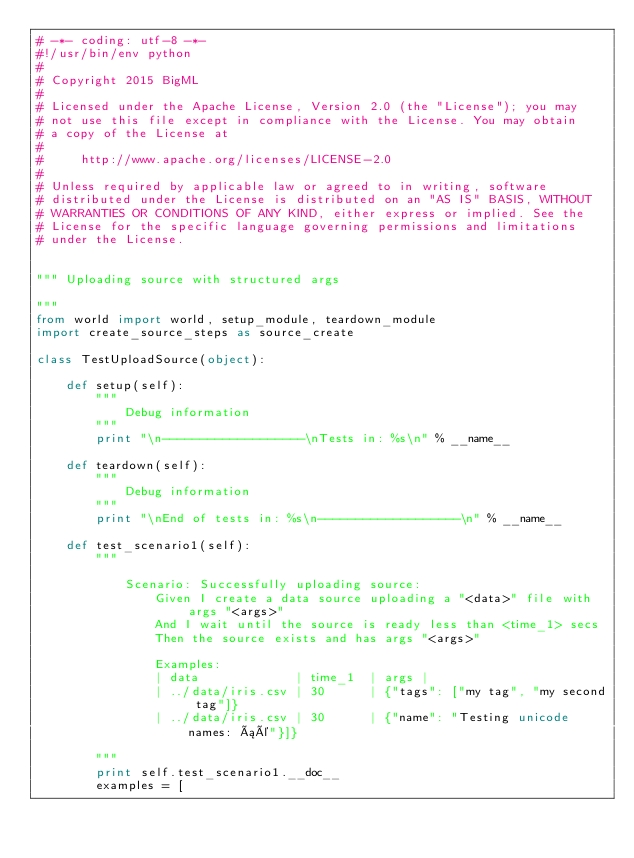<code> <loc_0><loc_0><loc_500><loc_500><_Python_># -*- coding: utf-8 -*-
#!/usr/bin/env python
#
# Copyright 2015 BigML
#
# Licensed under the Apache License, Version 2.0 (the "License"); you may
# not use this file except in compliance with the License. You may obtain
# a copy of the License at
#
#     http://www.apache.org/licenses/LICENSE-2.0
#
# Unless required by applicable law or agreed to in writing, software
# distributed under the License is distributed on an "AS IS" BASIS, WITHOUT
# WARRANTIES OR CONDITIONS OF ANY KIND, either express or implied. See the
# License for the specific language governing permissions and limitations
# under the License.


""" Uploading source with structured args

"""
from world import world, setup_module, teardown_module
import create_source_steps as source_create

class TestUploadSource(object):

    def setup(self):
        """
            Debug information
        """
        print "\n-------------------\nTests in: %s\n" % __name__

    def teardown(self):
        """
            Debug information
        """
        print "\nEnd of tests in: %s\n-------------------\n" % __name__

    def test_scenario1(self):
        """

            Scenario: Successfully uploading source:
                Given I create a data source uploading a "<data>" file with args "<args>"
                And I wait until the source is ready less than <time_1> secs
                Then the source exists and has args "<args>"

                Examples:
                | data             | time_1  | args |
                | ../data/iris.csv | 30      | {"tags": ["my tag", "my second tag"]}
                | ../data/iris.csv | 30      | {"name": "Testing unicode names: áé"}]}

        """
        print self.test_scenario1.__doc__
        examples = [</code> 